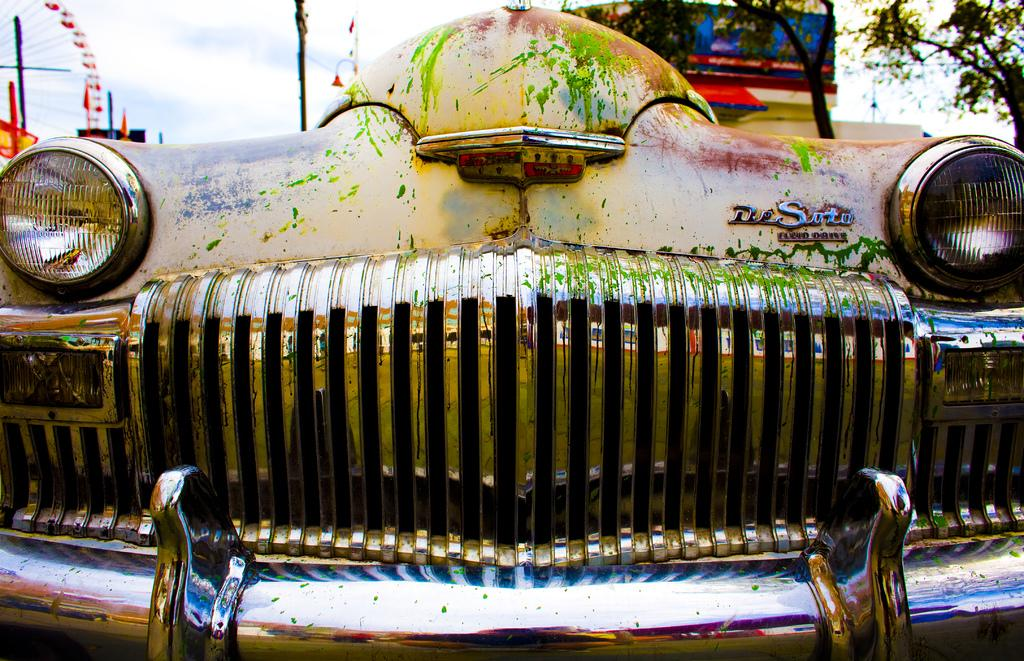What is the main subject of the zoomed-in picture? The main subject of the zoomed-in picture is a car. What can be seen in the background of the image? There are trees, a building, and a pole in the background of the image. What angle is the car positioned at in the image? The angle at which the car is positioned cannot be determined from the image. Is the car in the image a representative sample of all cars? The image does not provide enough information to determine if the car is a representative sample of all cars. 